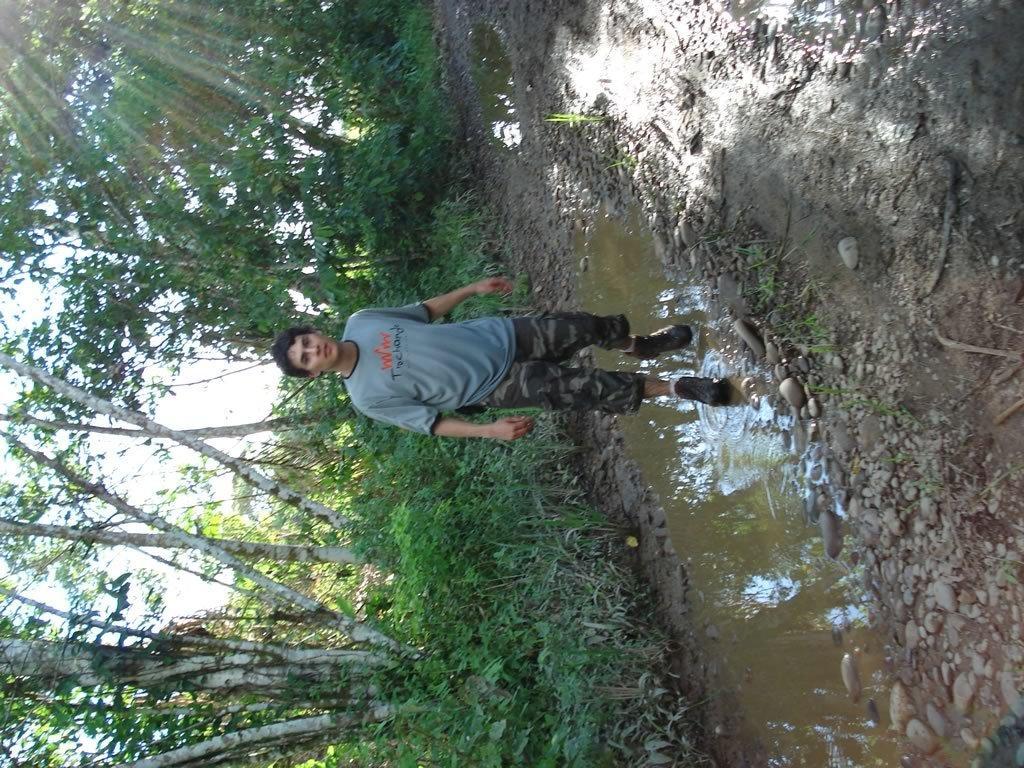How would you summarize this image in a sentence or two? In this picture there is a person standing in the water. At the back there are trees. At the top there is sky. At the bottom there are stones and there is water. 